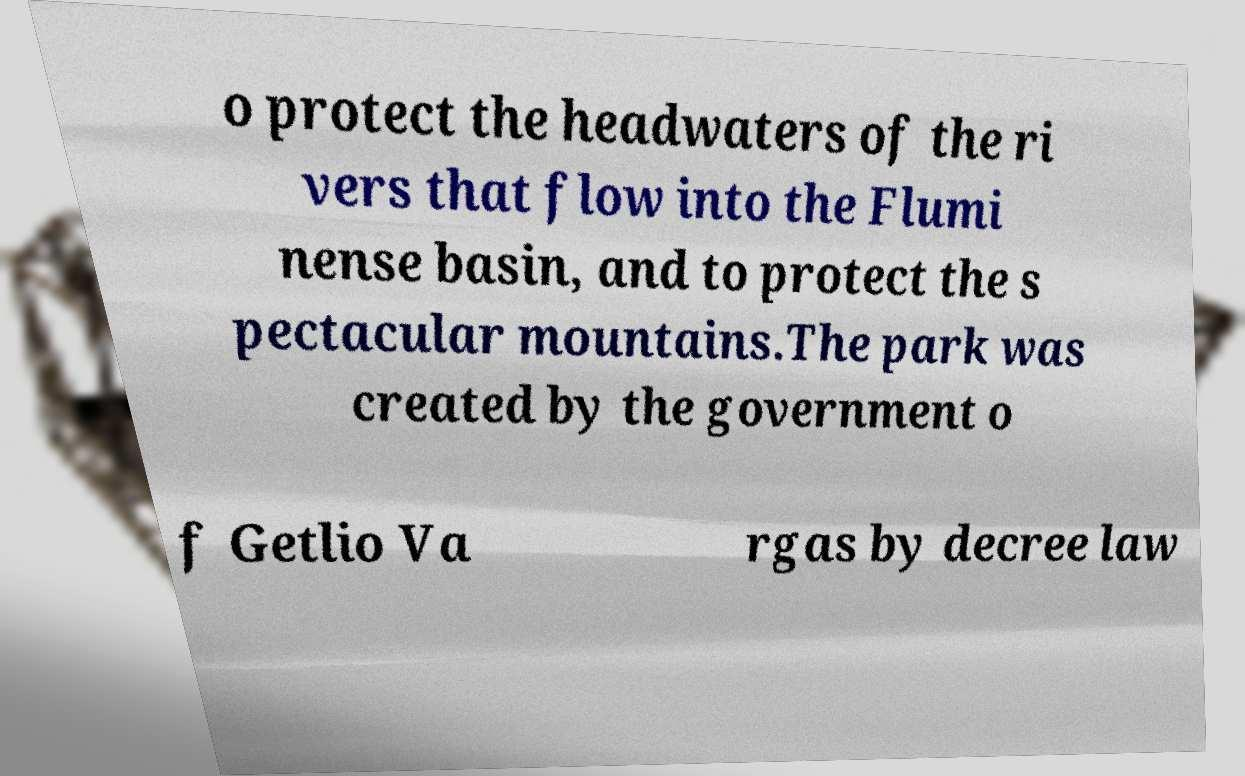For documentation purposes, I need the text within this image transcribed. Could you provide that? o protect the headwaters of the ri vers that flow into the Flumi nense basin, and to protect the s pectacular mountains.The park was created by the government o f Getlio Va rgas by decree law 